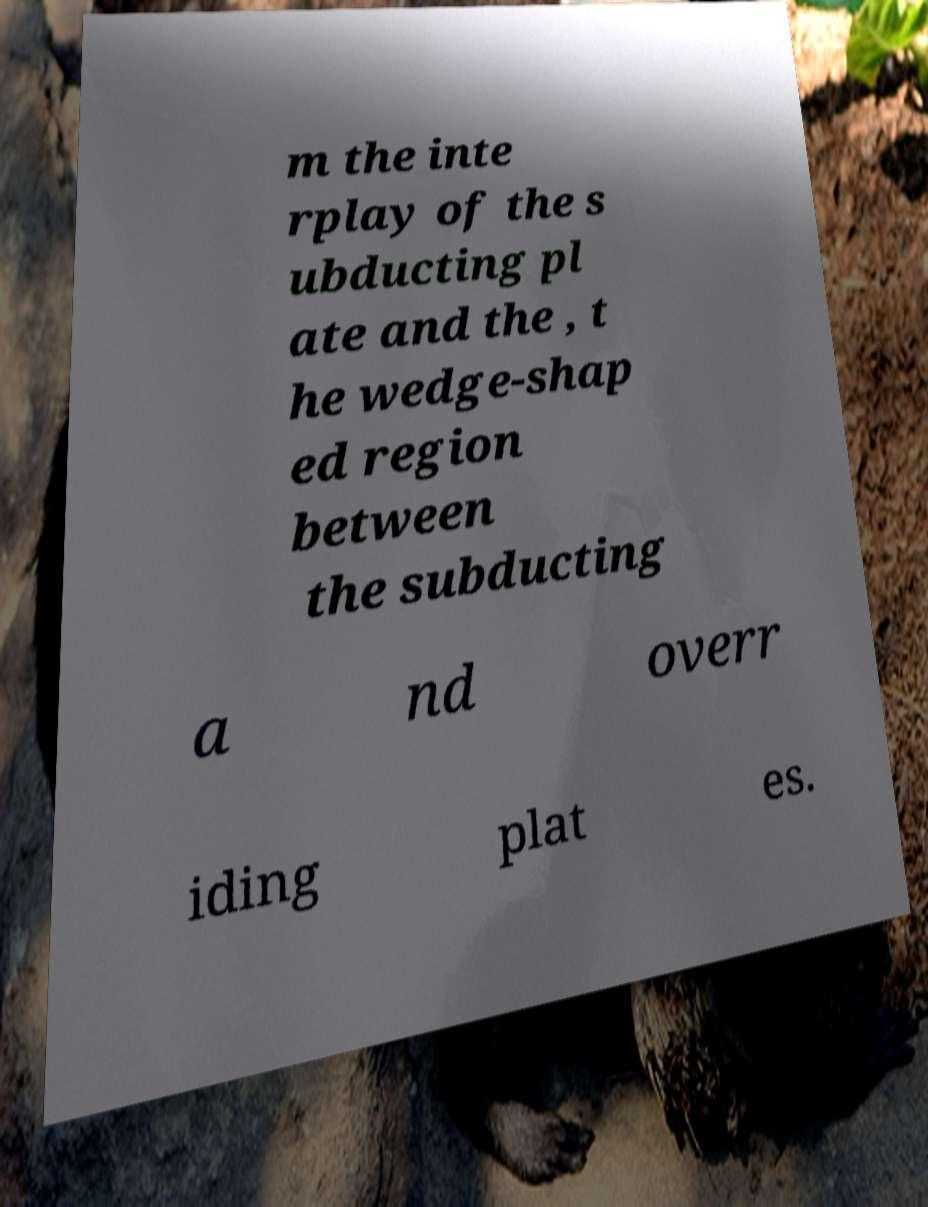Could you extract and type out the text from this image? m the inte rplay of the s ubducting pl ate and the , t he wedge-shap ed region between the subducting a nd overr iding plat es. 